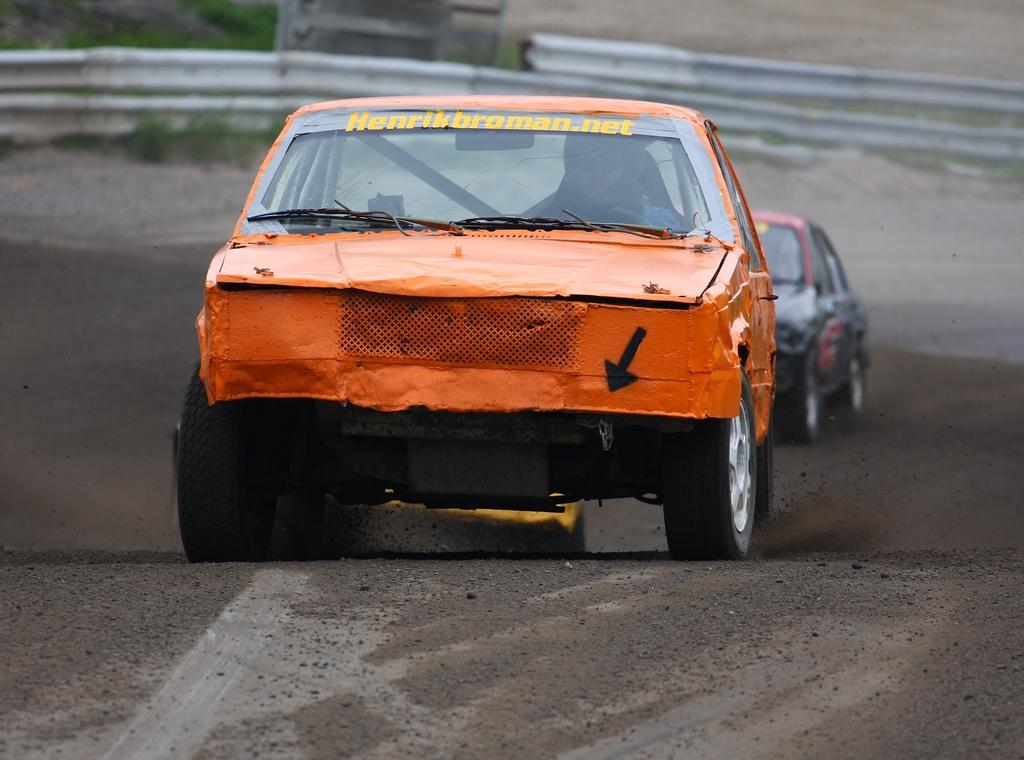How many cars are visible on the road in the image? There are two cars on the road in the image. What is located behind the cars in the image? There is a metal fence behind the cars. What type of scissors can be seen cutting the grass in the image? There are no scissors or grass present in the image; it features two cars on the road and a metal fence. What company is responsible for maintaining the road in the image? The image does not provide information about the company responsible for maintaining the road. 